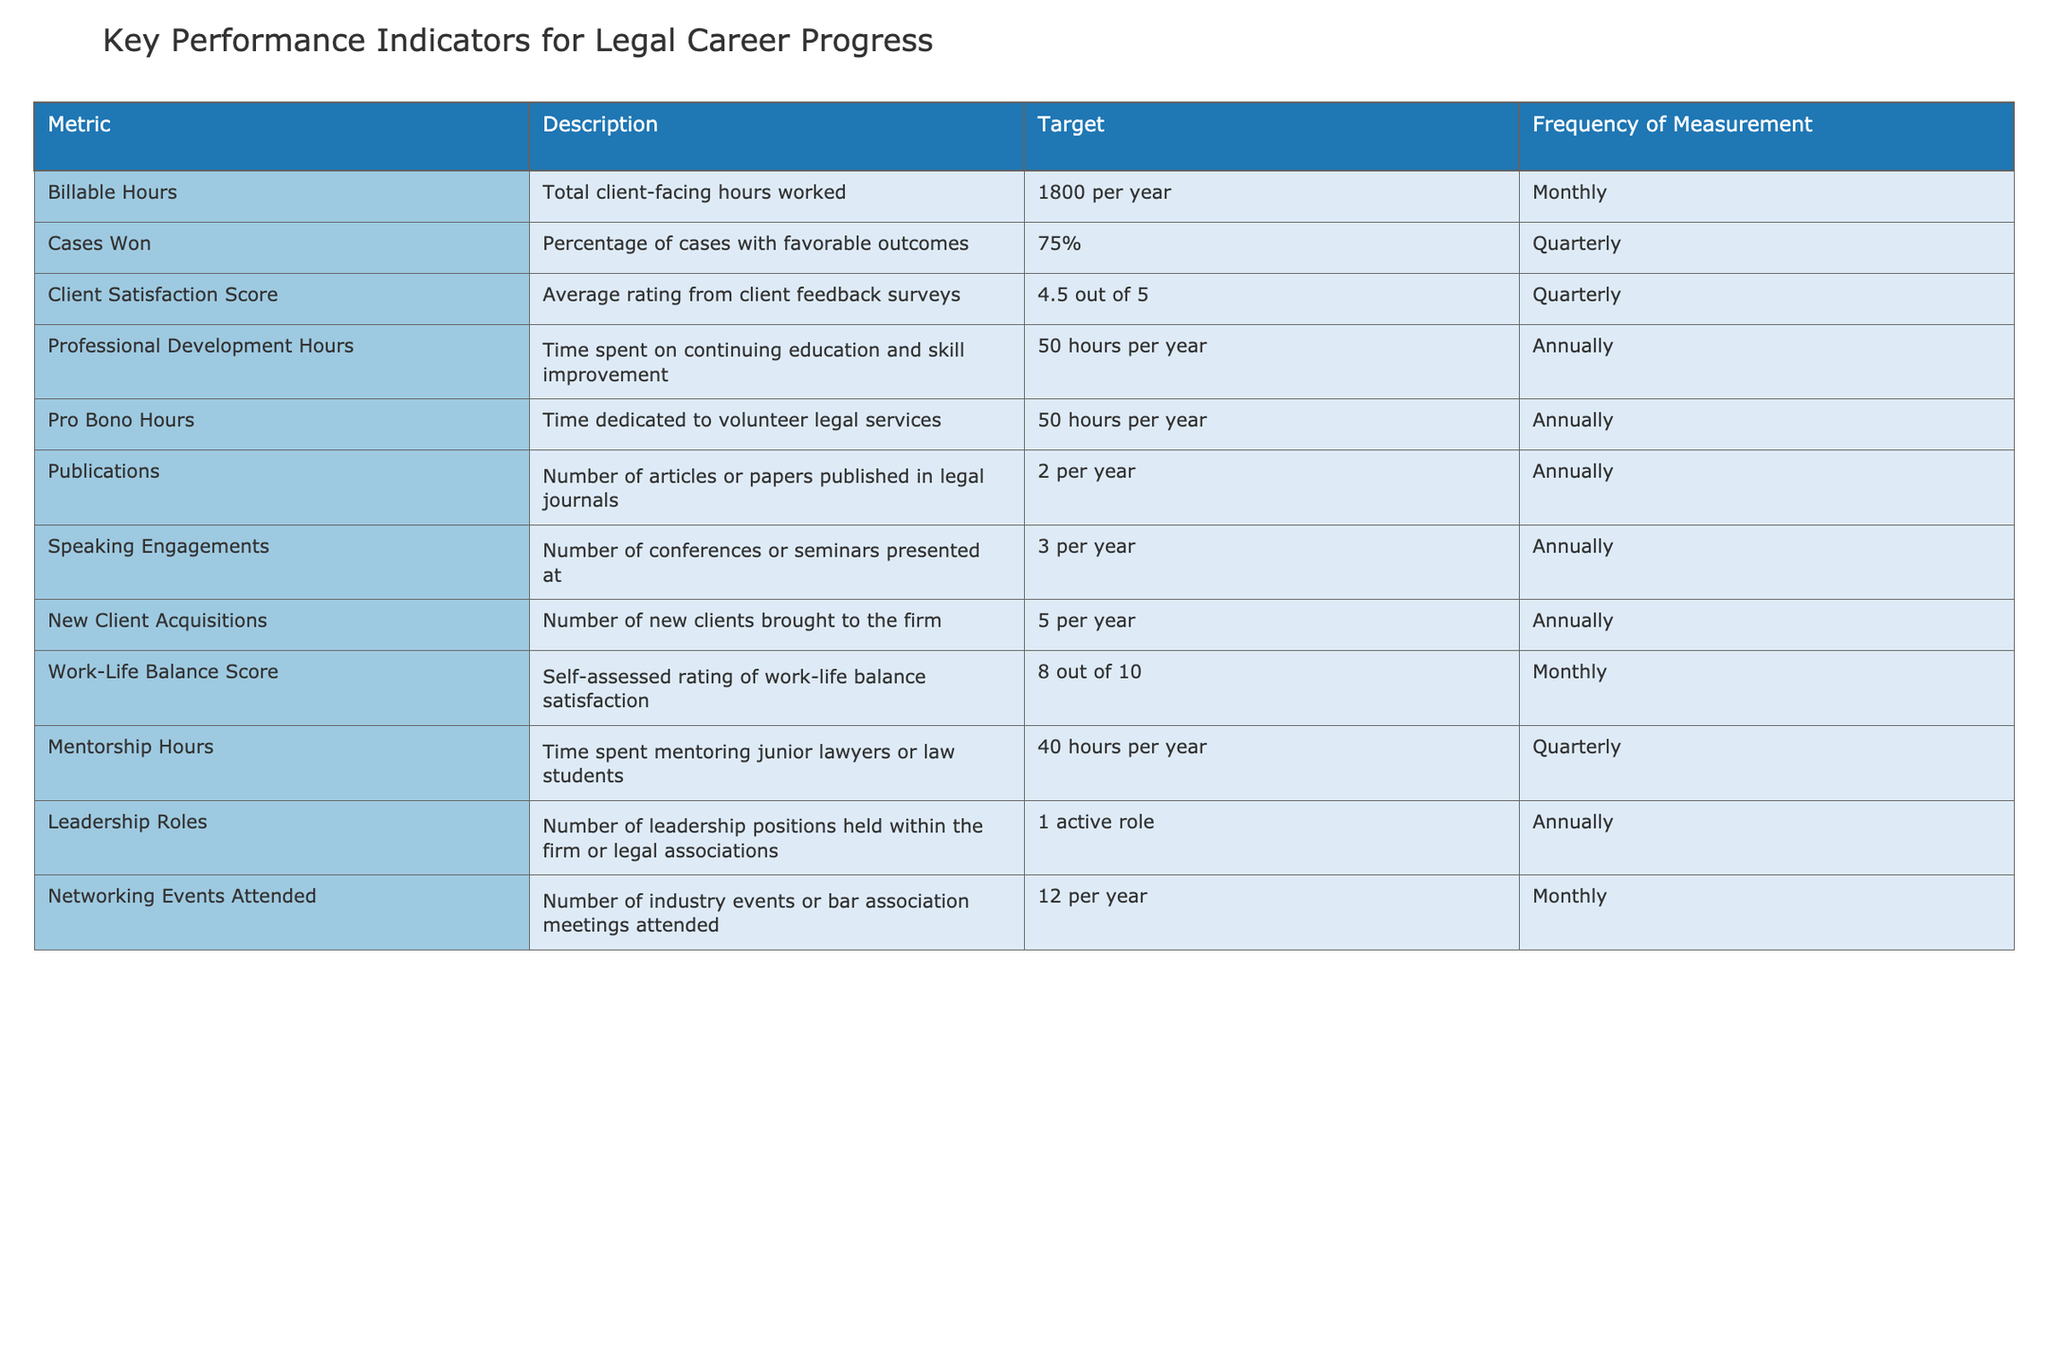What's the target for the number of billable hours per year? The target for billable hours is explicitly stated in the table under the "Target" column for "Billable Hours," which is 1800 per year.
Answer: 1800 per year How often is the Client Satisfaction Score measured? The frequency of measurement for the Client Satisfaction Score is stated in the "Frequency of Measurement" column. It is measured quarterly, as indicated next to "Client Satisfaction Score."
Answer: Quarterly What is the percentage of cases that need to be won to meet the target? The target percentage for winning cases is provided in the "Target" column next to "Cases Won," which is 75%.
Answer: 75% Are professional development hours measured on a monthly basis? The frequency of measurement for Professional Development Hours is listed as annual in the table, therefore it is not measured monthly.
Answer: No What is the total minimum number of Pro Bono Hours and Professional Development Hours expected per year? To find the total, sum the targets for Pro Bono Hours (50) and Professional Development Hours (50): 50 + 50 = 100.
Answer: 100 hours If a lawyer achieved 85% for Cases Won in a quarter, did they meet their target? The target for Cases Won is 75%. Since 85% is greater than 75%, the lawyer did meet their target for that quarter.
Answer: Yes What is the average number of speaking engagements and publications expected per year? The target for speaking engagements is 3 per year, and for publications, it is 2 per year. To find the average: (3 + 2) / 2 = 2.5.
Answer: 2.5 How many networking events should a lawyer attend to meet their annual goal? The target for Networking Events Attended is specified in the table as 12 per year under the respective metric.
Answer: 12 events If a lawyer has a Work-Life Balance Score of 7 out of 10, are they below their target? The target for Work-Life Balance Score is 8 out of 10. Since 7 is less than 8, they are below their target.
Answer: Yes What is the minimum number of new clients required to be acquired in a year to meet the target? The number of new clients required to acquire each year is explicitly stated as 5 per year in the "Target" column for New Client Acquisitions.
Answer: 5 clients 